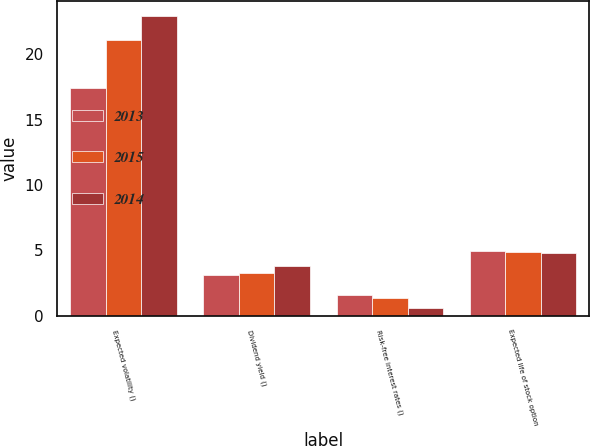Convert chart. <chart><loc_0><loc_0><loc_500><loc_500><stacked_bar_chart><ecel><fcel>Expected volatility ()<fcel>Dividend yield ()<fcel>Risk-free interest rates ()<fcel>Expected life of stock option<nl><fcel>2013<fcel>17.45<fcel>3.1<fcel>1.58<fcel>4.92<nl><fcel>2015<fcel>21.13<fcel>3.24<fcel>1.37<fcel>4.91<nl><fcel>2014<fcel>22.95<fcel>3.77<fcel>0.57<fcel>4.8<nl></chart> 